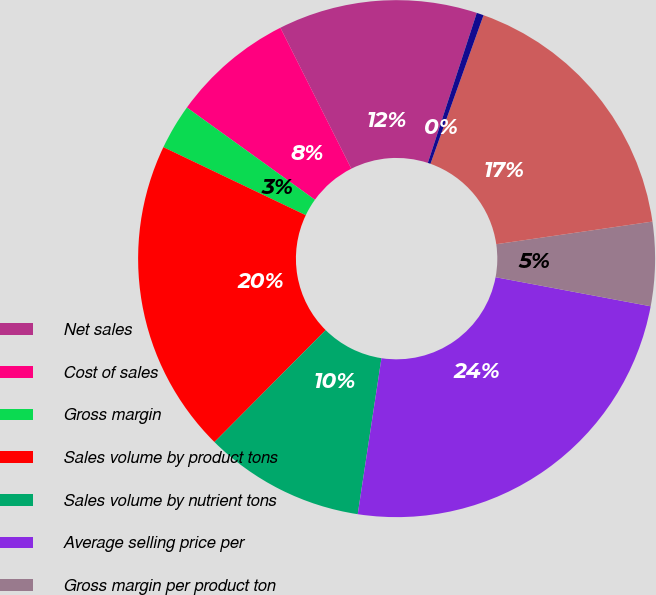Convert chart to OTSL. <chart><loc_0><loc_0><loc_500><loc_500><pie_chart><fcel>Net sales<fcel>Cost of sales<fcel>Gross margin<fcel>Sales volume by product tons<fcel>Sales volume by nutrient tons<fcel>Average selling price per<fcel>Gross margin per product ton<fcel>Gross margin per nutrient ton<fcel>Depreciation and amortization<nl><fcel>12.44%<fcel>7.64%<fcel>2.84%<fcel>19.65%<fcel>10.04%<fcel>24.45%<fcel>5.24%<fcel>17.25%<fcel>0.44%<nl></chart> 